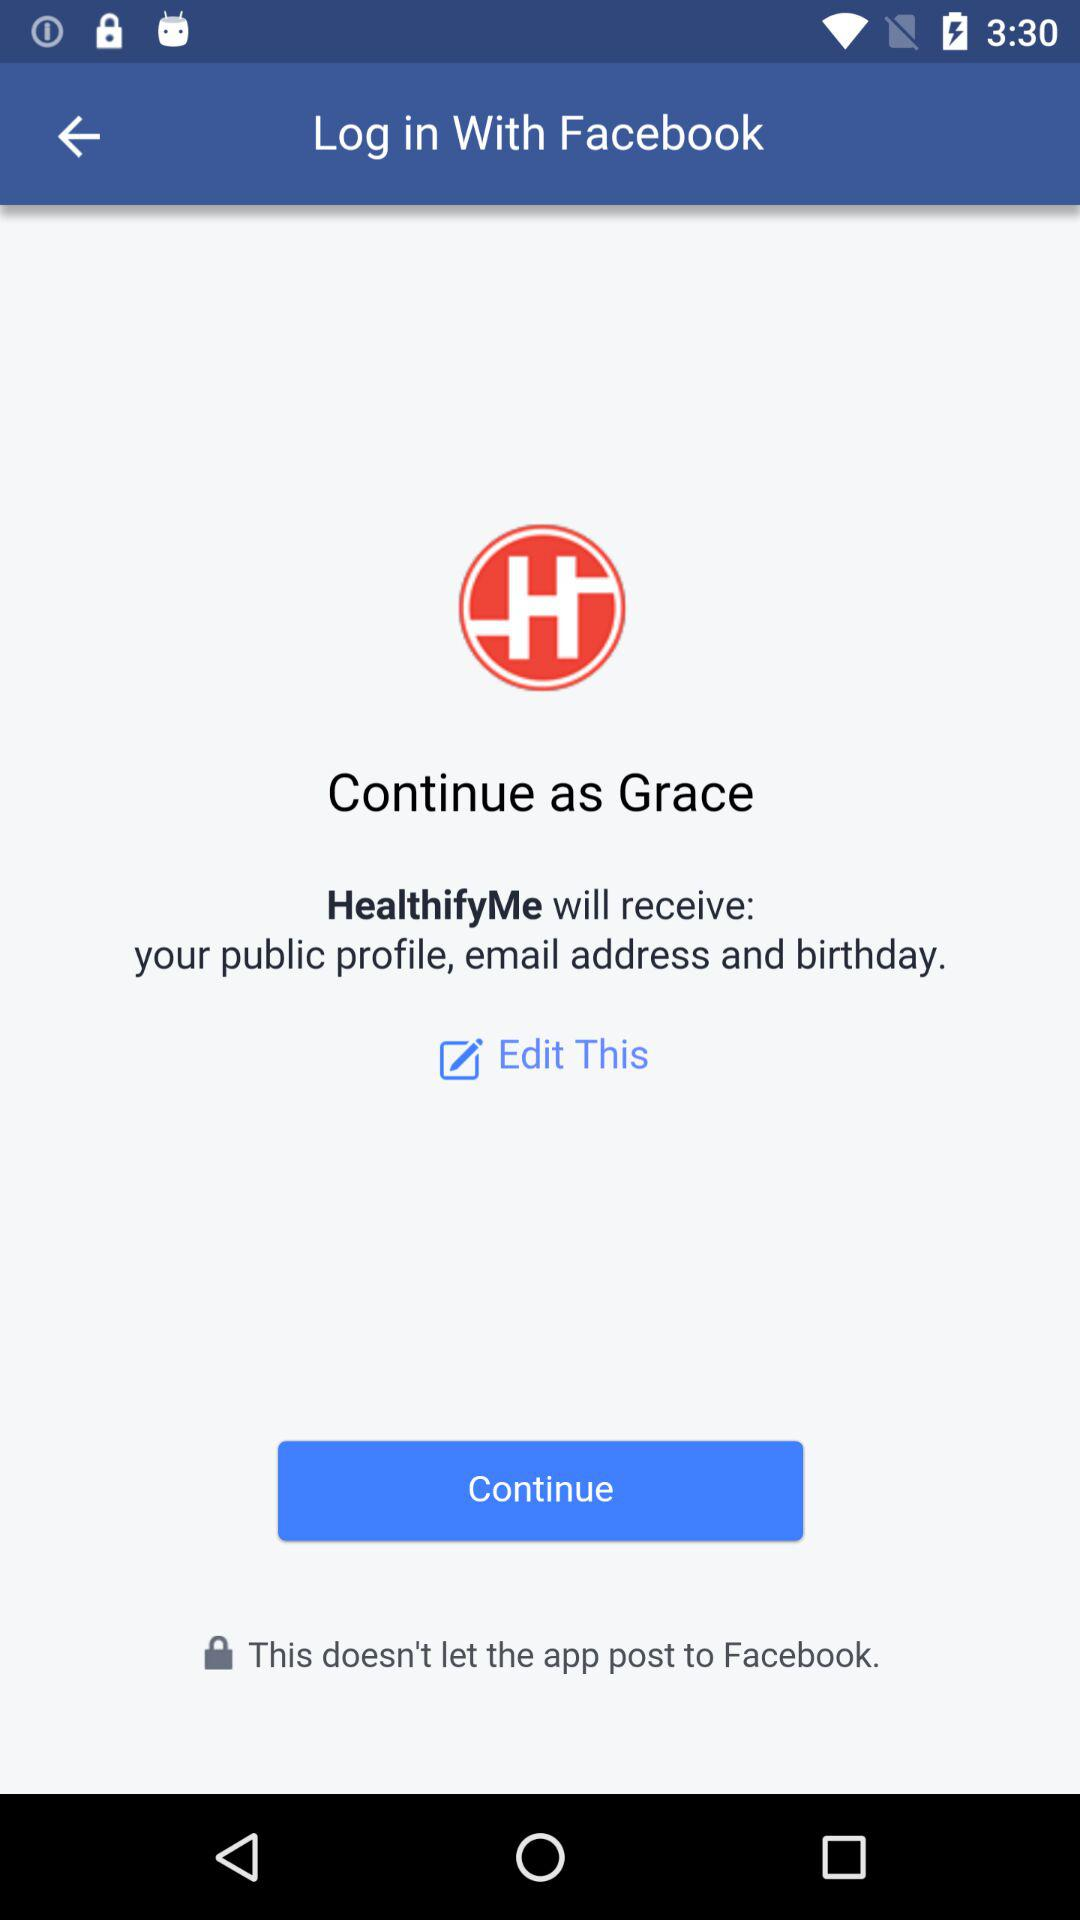What is the name of the user? The name of the user is Grace. 